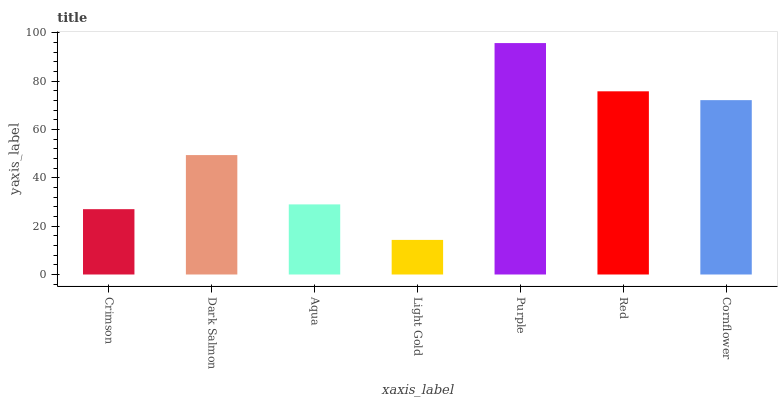Is Dark Salmon the minimum?
Answer yes or no. No. Is Dark Salmon the maximum?
Answer yes or no. No. Is Dark Salmon greater than Crimson?
Answer yes or no. Yes. Is Crimson less than Dark Salmon?
Answer yes or no. Yes. Is Crimson greater than Dark Salmon?
Answer yes or no. No. Is Dark Salmon less than Crimson?
Answer yes or no. No. Is Dark Salmon the high median?
Answer yes or no. Yes. Is Dark Salmon the low median?
Answer yes or no. Yes. Is Light Gold the high median?
Answer yes or no. No. Is Red the low median?
Answer yes or no. No. 